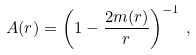<formula> <loc_0><loc_0><loc_500><loc_500>A ( r ) = \left ( 1 - \frac { 2 m ( r ) } { r } \right ) ^ { - 1 } \, ,</formula> 